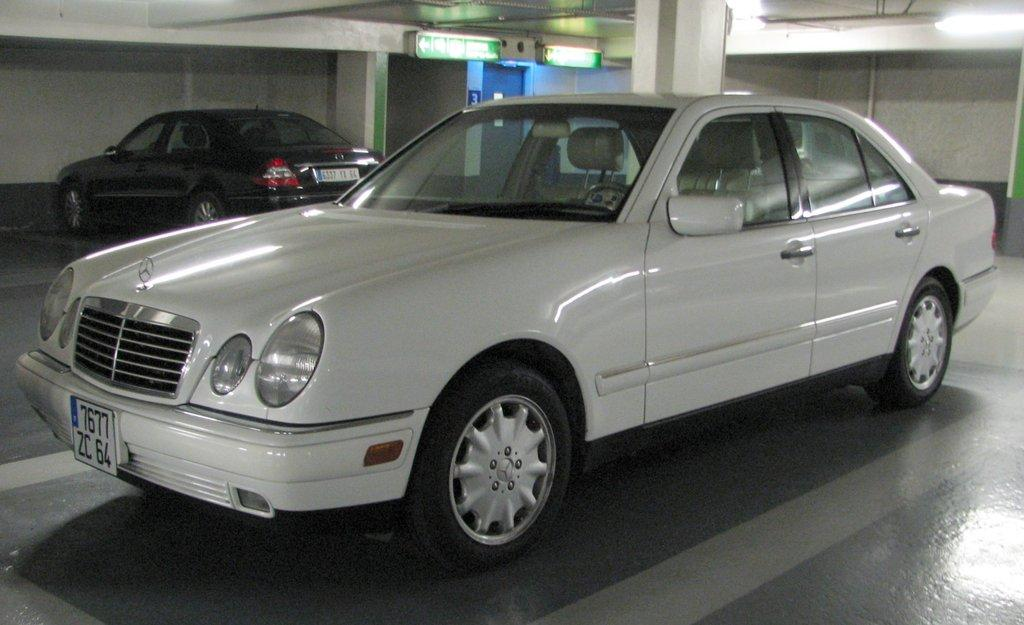How many cars are present in the image? There are two cars in the image. What colors are the cars? One car is white, and the other is black. What is the background of the image? There is a wall in the image. Are there any lighting features in the image? Yes, there are lights in the image. Where is the art piece displayed in the image? There is no art piece present in the image. Can you describe the man's attire in the image? There is no man present in the image. 